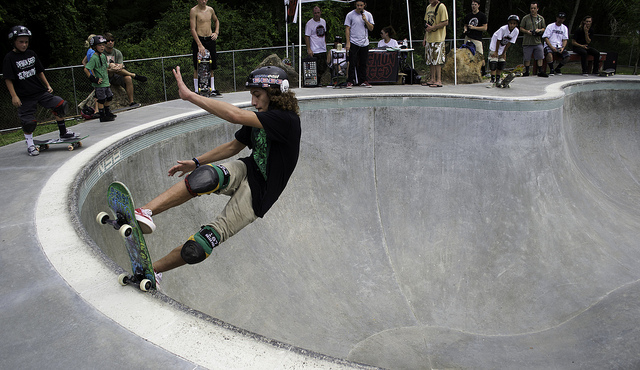How many skateboards can be seen? There is 1 skateboard visible in the image, skillfully maneuvered by the skater caught in mid-action within the smooth curves of the skate bowl. 